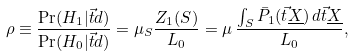Convert formula to latex. <formula><loc_0><loc_0><loc_500><loc_500>\rho \equiv \frac { \Pr ( H _ { 1 } | \vec { t } { d } ) } { \Pr ( H _ { 0 } | \vec { t } { d } ) } = \mu _ { S } \frac { Z _ { 1 } ( S ) } { L _ { 0 } } = \mu \, \frac { \int _ { S } \bar { P } _ { 1 } ( \vec { t } { \underline { X } } ) \, d \vec { t } { \underline { X } } } { L _ { 0 } } ,</formula> 